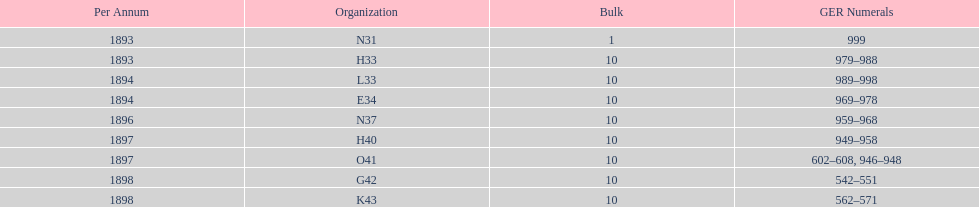Help me parse the entirety of this table. {'header': ['Per Annum', 'Organization', 'Bulk', 'GER Numerals'], 'rows': [['1893', 'N31', '1', '999'], ['1893', 'H33', '10', '979–988'], ['1894', 'L33', '10', '989–998'], ['1894', 'E34', '10', '969–978'], ['1896', 'N37', '10', '959–968'], ['1897', 'H40', '10', '949–958'], ['1897', 'O41', '10', '602–608, 946–948'], ['1898', 'G42', '10', '542–551'], ['1898', 'K43', '10', '562–571']]} When was g42, 1898 or 1894? 1898. 